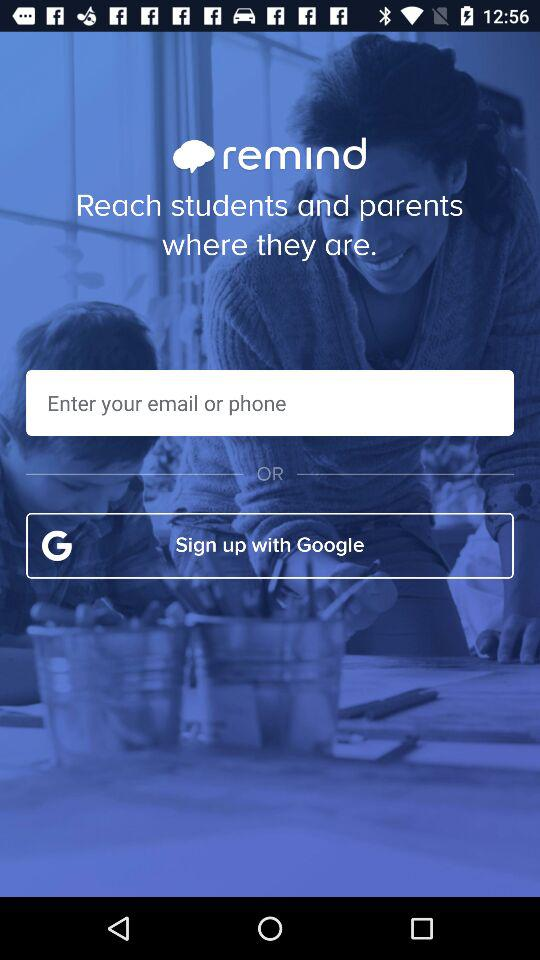How can we sign up? You can sign up with "Google". 